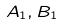<formula> <loc_0><loc_0><loc_500><loc_500>A _ { 1 } , B _ { 1 }</formula> 